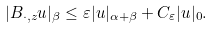Convert formula to latex. <formula><loc_0><loc_0><loc_500><loc_500>| B _ { \cdot , z } u | _ { \beta } \leq \varepsilon | u | _ { \alpha + \beta } + C _ { \varepsilon } | u | _ { 0 } .</formula> 